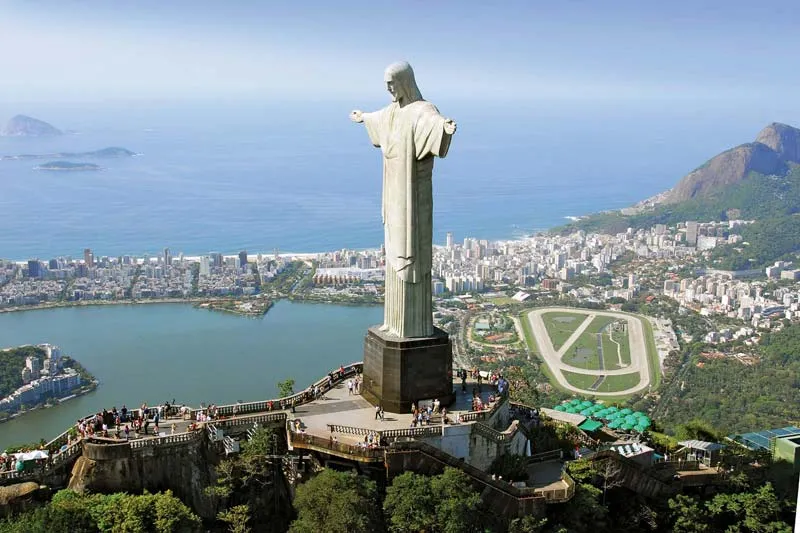Can you describe the main features of this image for me?
 The image captures the iconic Cristo Redentor, or Christ the Redeemer, standing majestically over Rio de Janeiro, Brazil. The statue, a large white figure of Jesus Christ, extends its arms in a welcoming gesture, embodying peace and openness. It stands on a pedestal, reinforcing its grandeur and prominence.

The perspective of the image is from a high angle, providing a breathtaking view of the statue against the backdrop of the vibrant city below. The urban landscape of Rio de Janeiro unfolds beneath the statue, with its mix of architectural styles nestled amidst lush green hills. The cityscape extends to meet the azure ocean, adding a serene touch to the dynamic scene.

In the foreground, a viewing platform is visible, dotted with tourists who add a sense of scale to the image. They are dwarfed by the statue, emphasizing its monumental size and significance.

The image is bathed in natural light, casting a warm glow on the statue and the city below. The clear blue sky forms the perfect canvas for this stunning scene, enhancing the overall visual impact of the image.

In summary, the image beautifully encapsulates the awe-inspiring presence of the Cristo Redentor, its symbiotic relationship with the city it watches over, and the natural beauty of Rio de Janeiro. It's a snapshot of a moment where human creativity, spiritual symbolism, and natural beauty converge in harmony. 